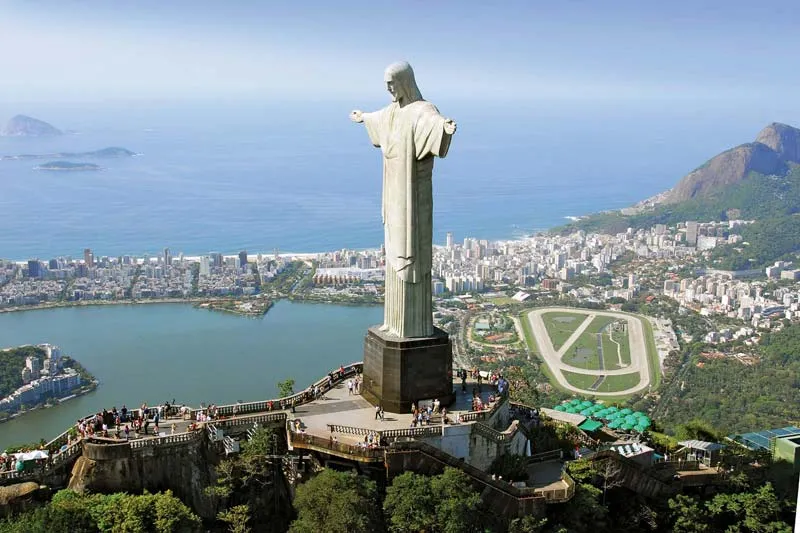Can you describe the main features of this image for me?
 The image captures the iconic Cristo Redentor, or Christ the Redeemer, standing majestically over Rio de Janeiro, Brazil. The statue, a large white figure of Jesus Christ, extends its arms in a welcoming gesture, embodying peace and openness. It stands on a pedestal, reinforcing its grandeur and prominence.

The perspective of the image is from a high angle, providing a breathtaking view of the statue against the backdrop of the vibrant city below. The urban landscape of Rio de Janeiro unfolds beneath the statue, with its mix of architectural styles nestled amidst lush green hills. The cityscape extends to meet the azure ocean, adding a serene touch to the dynamic scene.

In the foreground, a viewing platform is visible, dotted with tourists who add a sense of scale to the image. They are dwarfed by the statue, emphasizing its monumental size and significance.

The image is bathed in natural light, casting a warm glow on the statue and the city below. The clear blue sky forms the perfect canvas for this stunning scene, enhancing the overall visual impact of the image.

In summary, the image beautifully encapsulates the awe-inspiring presence of the Cristo Redentor, its symbiotic relationship with the city it watches over, and the natural beauty of Rio de Janeiro. It's a snapshot of a moment where human creativity, spiritual symbolism, and natural beauty converge in harmony. 